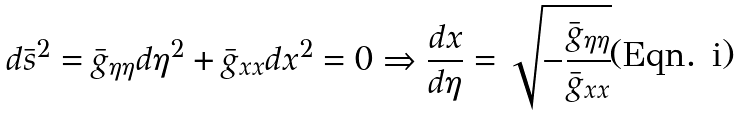Convert formula to latex. <formula><loc_0><loc_0><loc_500><loc_500>d \bar { s } ^ { 2 } = \bar { g } _ { \eta \eta } d \eta ^ { 2 } + \bar { g } _ { x x } d x ^ { 2 } = 0 \Rightarrow \frac { d x } { d \eta } = \sqrt { - \frac { \bar { g } _ { \eta \eta } } { \bar { g } _ { x x } } }</formula> 